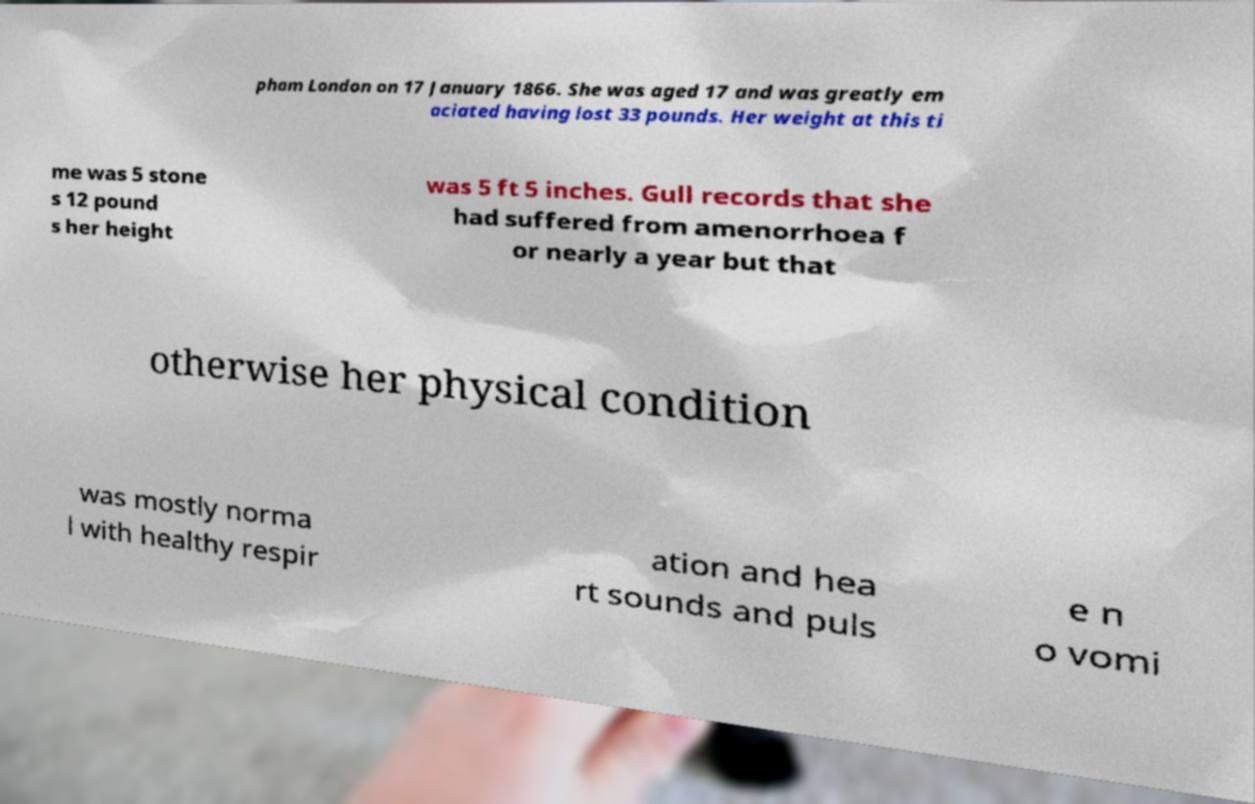Can you read and provide the text displayed in the image?This photo seems to have some interesting text. Can you extract and type it out for me? pham London on 17 January 1866. She was aged 17 and was greatly em aciated having lost 33 pounds. Her weight at this ti me was 5 stone s 12 pound s her height was 5 ft 5 inches. Gull records that she had suffered from amenorrhoea f or nearly a year but that otherwise her physical condition was mostly norma l with healthy respir ation and hea rt sounds and puls e n o vomi 